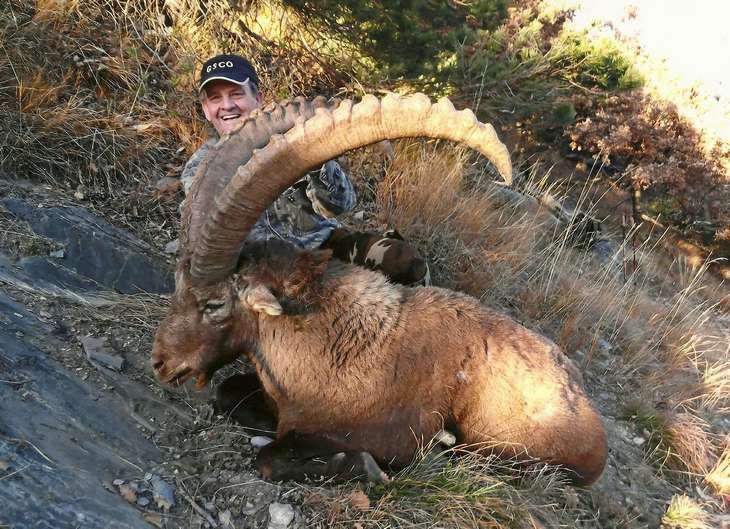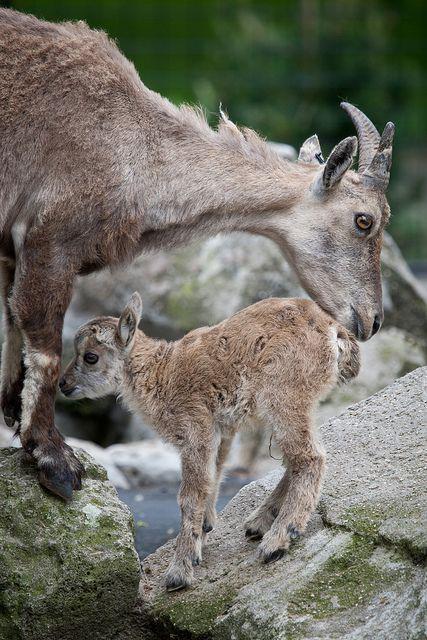The first image is the image on the left, the second image is the image on the right. Given the left and right images, does the statement "A long horn sheep is laying on the ground" hold true? Answer yes or no. Yes. The first image is the image on the left, the second image is the image on the right. Evaluate the accuracy of this statement regarding the images: "The are two mountain goats on the left image.". Is it true? Answer yes or no. No. 